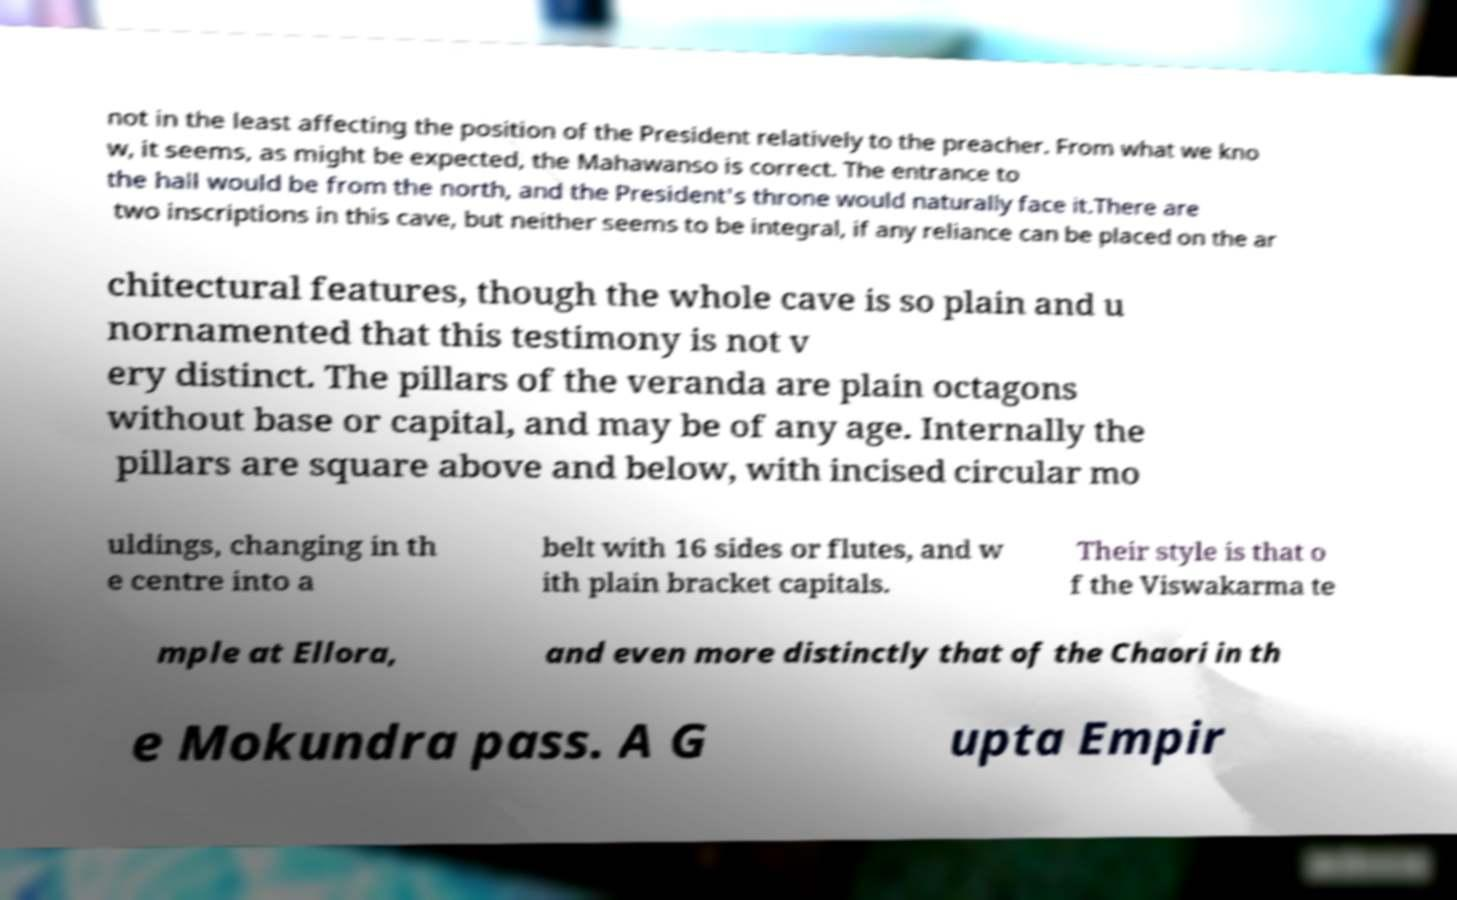Could you extract and type out the text from this image? not in the least affecting the position of the President relatively to the preacher. From what we kno w, it seems, as might be expected, the Mahawanso is correct. The entrance to the hall would be from the north, and the President's throne would naturally face it.There are two inscriptions in this cave, but neither seems to be integral, if any reliance can be placed on the ar chitectural features, though the whole cave is so plain and u nornamented that this testimony is not v ery distinct. The pillars of the veranda are plain octagons without base or capital, and may be of any age. Internally the pillars are square above and below, with incised circular mo uldings, changing in th e centre into a belt with 16 sides or flutes, and w ith plain bracket capitals. Their style is that o f the Viswakarma te mple at Ellora, and even more distinctly that of the Chaori in th e Mokundra pass. A G upta Empir 